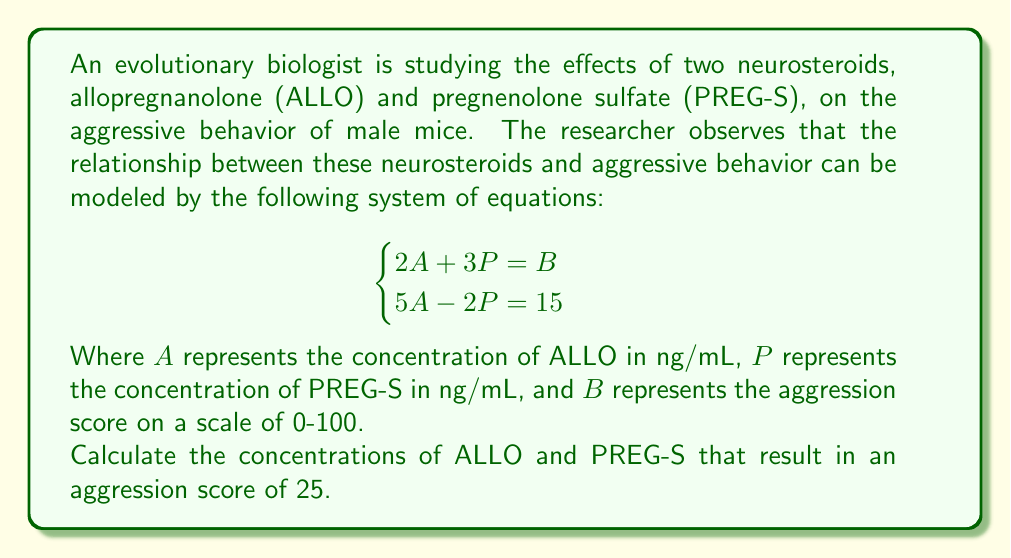Can you answer this question? To solve this problem, we'll use the substitution method for solving systems of equations:

1) From the second equation, we can express $A$ in terms of $P$:
   $5A - 2P = 15$
   $5A = 2P + 15$
   $A = \frac{2P + 15}{5}$

2) Substitute this expression for $A$ into the first equation:
   $2(\frac{2P + 15}{5}) + 3P = B$
   $\frac{4P + 30}{5} + 3P = 25$ (since $B = 25$ in this case)

3) Multiply both sides by 5 to eliminate fractions:
   $4P + 30 + 15P = 125$
   $19P + 30 = 125$
   $19P = 95$
   $P = 5$

4) Now that we know $P$, we can substitute back into the equation for $A$:
   $A = \frac{2(5) + 15}{5} = \frac{25}{5} = 5$

5) To verify, let's check if these values satisfy both original equations:
   $2(5) + 3(5) = 25$ (first equation)
   $5(5) - 2(5) = 15$ (second equation)
   Both equations are satisfied.
Answer: The concentrations that result in an aggression score of 25 are:
ALLO (A) = 5 ng/mL
PREG-S (P) = 5 ng/mL 